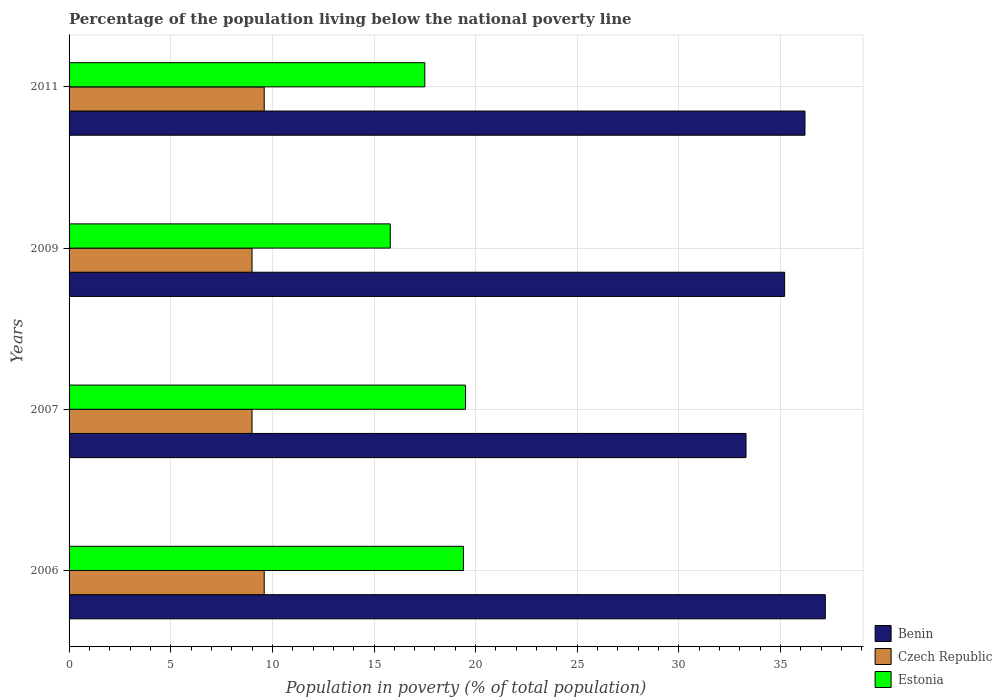How many different coloured bars are there?
Your response must be concise. 3. How many bars are there on the 2nd tick from the top?
Offer a very short reply. 3. In how many cases, is the number of bars for a given year not equal to the number of legend labels?
Your answer should be very brief. 0. Across all years, what is the maximum percentage of the population living below the national poverty line in Benin?
Your answer should be compact. 37.2. In which year was the percentage of the population living below the national poverty line in Czech Republic minimum?
Offer a terse response. 2007. What is the total percentage of the population living below the national poverty line in Benin in the graph?
Provide a short and direct response. 141.9. What is the difference between the percentage of the population living below the national poverty line in Benin in 2006 and that in 2007?
Your answer should be compact. 3.9. What is the difference between the percentage of the population living below the national poverty line in Estonia in 2006 and the percentage of the population living below the national poverty line in Benin in 2009?
Your answer should be compact. -15.8. What is the average percentage of the population living below the national poverty line in Benin per year?
Make the answer very short. 35.48. In the year 2011, what is the difference between the percentage of the population living below the national poverty line in Benin and percentage of the population living below the national poverty line in Czech Republic?
Provide a short and direct response. 26.6. What is the difference between the highest and the lowest percentage of the population living below the national poverty line in Benin?
Make the answer very short. 3.9. In how many years, is the percentage of the population living below the national poverty line in Benin greater than the average percentage of the population living below the national poverty line in Benin taken over all years?
Your response must be concise. 2. Is the sum of the percentage of the population living below the national poverty line in Czech Republic in 2007 and 2009 greater than the maximum percentage of the population living below the national poverty line in Estonia across all years?
Give a very brief answer. No. What does the 1st bar from the top in 2011 represents?
Make the answer very short. Estonia. What does the 2nd bar from the bottom in 2007 represents?
Give a very brief answer. Czech Republic. Is it the case that in every year, the sum of the percentage of the population living below the national poverty line in Estonia and percentage of the population living below the national poverty line in Czech Republic is greater than the percentage of the population living below the national poverty line in Benin?
Give a very brief answer. No. Are all the bars in the graph horizontal?
Your answer should be very brief. Yes. How many years are there in the graph?
Provide a succinct answer. 4. What is the difference between two consecutive major ticks on the X-axis?
Your answer should be compact. 5. Does the graph contain grids?
Offer a terse response. Yes. How many legend labels are there?
Keep it short and to the point. 3. How are the legend labels stacked?
Provide a succinct answer. Vertical. What is the title of the graph?
Make the answer very short. Percentage of the population living below the national poverty line. What is the label or title of the X-axis?
Make the answer very short. Population in poverty (% of total population). What is the Population in poverty (% of total population) of Benin in 2006?
Offer a very short reply. 37.2. What is the Population in poverty (% of total population) of Czech Republic in 2006?
Keep it short and to the point. 9.6. What is the Population in poverty (% of total population) of Benin in 2007?
Provide a succinct answer. 33.3. What is the Population in poverty (% of total population) in Czech Republic in 2007?
Your response must be concise. 9. What is the Population in poverty (% of total population) in Benin in 2009?
Keep it short and to the point. 35.2. What is the Population in poverty (% of total population) in Benin in 2011?
Provide a succinct answer. 36.2. What is the Population in poverty (% of total population) of Czech Republic in 2011?
Give a very brief answer. 9.6. What is the Population in poverty (% of total population) of Estonia in 2011?
Offer a terse response. 17.5. Across all years, what is the maximum Population in poverty (% of total population) of Benin?
Your answer should be very brief. 37.2. Across all years, what is the maximum Population in poverty (% of total population) in Estonia?
Your answer should be compact. 19.5. Across all years, what is the minimum Population in poverty (% of total population) of Benin?
Keep it short and to the point. 33.3. What is the total Population in poverty (% of total population) in Benin in the graph?
Your answer should be compact. 141.9. What is the total Population in poverty (% of total population) in Czech Republic in the graph?
Give a very brief answer. 37.2. What is the total Population in poverty (% of total population) in Estonia in the graph?
Your response must be concise. 72.2. What is the difference between the Population in poverty (% of total population) in Benin in 2006 and that in 2007?
Keep it short and to the point. 3.9. What is the difference between the Population in poverty (% of total population) in Estonia in 2006 and that in 2007?
Your answer should be very brief. -0.1. What is the difference between the Population in poverty (% of total population) in Czech Republic in 2006 and that in 2009?
Offer a terse response. 0.6. What is the difference between the Population in poverty (% of total population) in Estonia in 2006 and that in 2009?
Your answer should be compact. 3.6. What is the difference between the Population in poverty (% of total population) of Czech Republic in 2006 and that in 2011?
Offer a terse response. 0. What is the difference between the Population in poverty (% of total population) of Estonia in 2006 and that in 2011?
Keep it short and to the point. 1.9. What is the difference between the Population in poverty (% of total population) of Benin in 2007 and that in 2009?
Your answer should be compact. -1.9. What is the difference between the Population in poverty (% of total population) in Czech Republic in 2007 and that in 2011?
Ensure brevity in your answer.  -0.6. What is the difference between the Population in poverty (% of total population) of Czech Republic in 2009 and that in 2011?
Your answer should be very brief. -0.6. What is the difference between the Population in poverty (% of total population) in Benin in 2006 and the Population in poverty (% of total population) in Czech Republic in 2007?
Provide a short and direct response. 28.2. What is the difference between the Population in poverty (% of total population) of Benin in 2006 and the Population in poverty (% of total population) of Estonia in 2007?
Your response must be concise. 17.7. What is the difference between the Population in poverty (% of total population) in Benin in 2006 and the Population in poverty (% of total population) in Czech Republic in 2009?
Give a very brief answer. 28.2. What is the difference between the Population in poverty (% of total population) of Benin in 2006 and the Population in poverty (% of total population) of Estonia in 2009?
Ensure brevity in your answer.  21.4. What is the difference between the Population in poverty (% of total population) of Benin in 2006 and the Population in poverty (% of total population) of Czech Republic in 2011?
Provide a short and direct response. 27.6. What is the difference between the Population in poverty (% of total population) of Benin in 2006 and the Population in poverty (% of total population) of Estonia in 2011?
Provide a short and direct response. 19.7. What is the difference between the Population in poverty (% of total population) of Czech Republic in 2006 and the Population in poverty (% of total population) of Estonia in 2011?
Keep it short and to the point. -7.9. What is the difference between the Population in poverty (% of total population) in Benin in 2007 and the Population in poverty (% of total population) in Czech Republic in 2009?
Give a very brief answer. 24.3. What is the difference between the Population in poverty (% of total population) in Benin in 2007 and the Population in poverty (% of total population) in Estonia in 2009?
Your answer should be very brief. 17.5. What is the difference between the Population in poverty (% of total population) in Czech Republic in 2007 and the Population in poverty (% of total population) in Estonia in 2009?
Keep it short and to the point. -6.8. What is the difference between the Population in poverty (% of total population) in Benin in 2007 and the Population in poverty (% of total population) in Czech Republic in 2011?
Ensure brevity in your answer.  23.7. What is the difference between the Population in poverty (% of total population) of Czech Republic in 2007 and the Population in poverty (% of total population) of Estonia in 2011?
Offer a terse response. -8.5. What is the difference between the Population in poverty (% of total population) in Benin in 2009 and the Population in poverty (% of total population) in Czech Republic in 2011?
Provide a short and direct response. 25.6. What is the difference between the Population in poverty (% of total population) in Benin in 2009 and the Population in poverty (% of total population) in Estonia in 2011?
Your answer should be compact. 17.7. What is the difference between the Population in poverty (% of total population) of Czech Republic in 2009 and the Population in poverty (% of total population) of Estonia in 2011?
Offer a very short reply. -8.5. What is the average Population in poverty (% of total population) in Benin per year?
Your answer should be compact. 35.48. What is the average Population in poverty (% of total population) in Czech Republic per year?
Make the answer very short. 9.3. What is the average Population in poverty (% of total population) of Estonia per year?
Offer a terse response. 18.05. In the year 2006, what is the difference between the Population in poverty (% of total population) of Benin and Population in poverty (% of total population) of Czech Republic?
Give a very brief answer. 27.6. In the year 2006, what is the difference between the Population in poverty (% of total population) in Czech Republic and Population in poverty (% of total population) in Estonia?
Your answer should be very brief. -9.8. In the year 2007, what is the difference between the Population in poverty (% of total population) of Benin and Population in poverty (% of total population) of Czech Republic?
Provide a succinct answer. 24.3. In the year 2007, what is the difference between the Population in poverty (% of total population) in Czech Republic and Population in poverty (% of total population) in Estonia?
Provide a short and direct response. -10.5. In the year 2009, what is the difference between the Population in poverty (% of total population) in Benin and Population in poverty (% of total population) in Czech Republic?
Provide a succinct answer. 26.2. In the year 2011, what is the difference between the Population in poverty (% of total population) in Benin and Population in poverty (% of total population) in Czech Republic?
Your response must be concise. 26.6. In the year 2011, what is the difference between the Population in poverty (% of total population) in Benin and Population in poverty (% of total population) in Estonia?
Your response must be concise. 18.7. In the year 2011, what is the difference between the Population in poverty (% of total population) of Czech Republic and Population in poverty (% of total population) of Estonia?
Make the answer very short. -7.9. What is the ratio of the Population in poverty (% of total population) of Benin in 2006 to that in 2007?
Ensure brevity in your answer.  1.12. What is the ratio of the Population in poverty (% of total population) in Czech Republic in 2006 to that in 2007?
Ensure brevity in your answer.  1.07. What is the ratio of the Population in poverty (% of total population) in Benin in 2006 to that in 2009?
Offer a very short reply. 1.06. What is the ratio of the Population in poverty (% of total population) in Czech Republic in 2006 to that in 2009?
Offer a very short reply. 1.07. What is the ratio of the Population in poverty (% of total population) in Estonia in 2006 to that in 2009?
Keep it short and to the point. 1.23. What is the ratio of the Population in poverty (% of total population) of Benin in 2006 to that in 2011?
Provide a short and direct response. 1.03. What is the ratio of the Population in poverty (% of total population) of Estonia in 2006 to that in 2011?
Provide a short and direct response. 1.11. What is the ratio of the Population in poverty (% of total population) in Benin in 2007 to that in 2009?
Offer a very short reply. 0.95. What is the ratio of the Population in poverty (% of total population) in Estonia in 2007 to that in 2009?
Provide a short and direct response. 1.23. What is the ratio of the Population in poverty (% of total population) of Benin in 2007 to that in 2011?
Your answer should be compact. 0.92. What is the ratio of the Population in poverty (% of total population) in Estonia in 2007 to that in 2011?
Your answer should be very brief. 1.11. What is the ratio of the Population in poverty (% of total population) of Benin in 2009 to that in 2011?
Keep it short and to the point. 0.97. What is the ratio of the Population in poverty (% of total population) of Estonia in 2009 to that in 2011?
Provide a succinct answer. 0.9. What is the difference between the highest and the second highest Population in poverty (% of total population) in Benin?
Offer a terse response. 1. What is the difference between the highest and the second highest Population in poverty (% of total population) in Estonia?
Ensure brevity in your answer.  0.1. What is the difference between the highest and the lowest Population in poverty (% of total population) in Benin?
Keep it short and to the point. 3.9. 